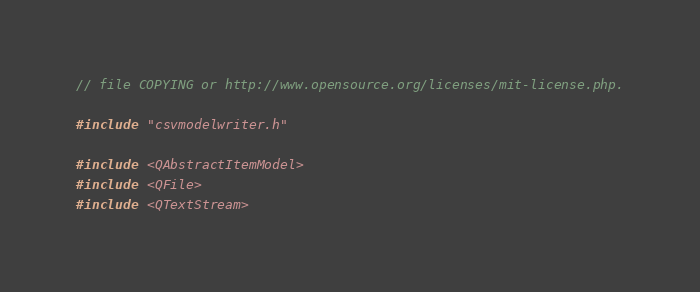<code> <loc_0><loc_0><loc_500><loc_500><_C++_>// file COPYING or http://www.opensource.org/licenses/mit-license.php.

#include "csvmodelwriter.h"

#include <QAbstractItemModel>
#include <QFile>
#include <QTextStream>
</code> 